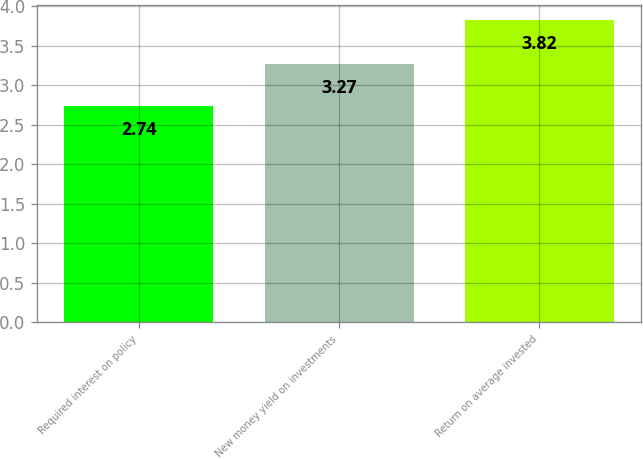Convert chart. <chart><loc_0><loc_0><loc_500><loc_500><bar_chart><fcel>Required interest on policy<fcel>New money yield on investments<fcel>Return on average invested<nl><fcel>2.74<fcel>3.27<fcel>3.82<nl></chart> 